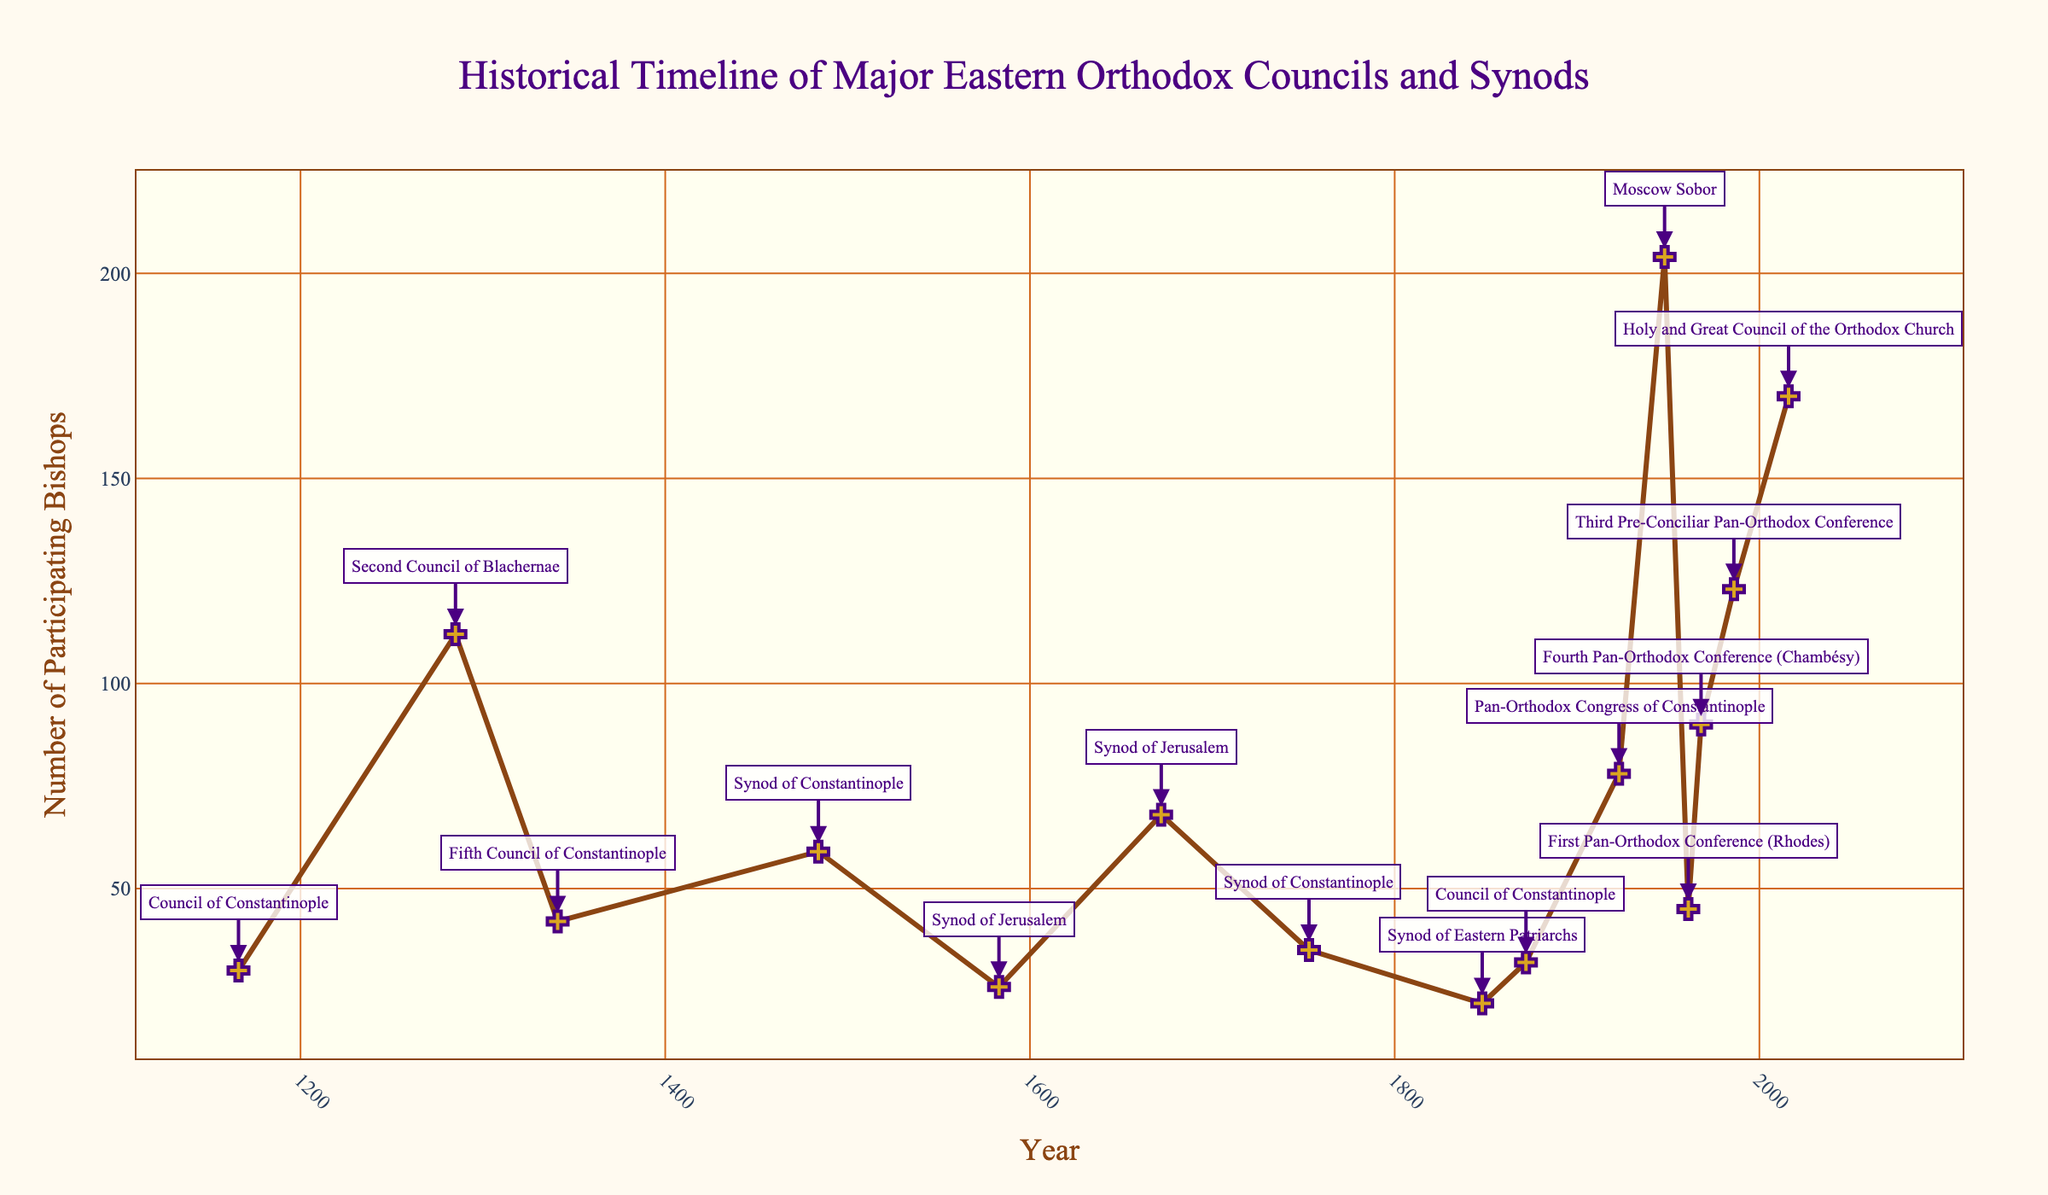Which council had the highest number of participating bishops? Observe the highest point on the y-axis of the plot and note the corresponding year and council/synod annotation. The peak is reached at the Moscow Sobor in 1948 with 204 bishops.
Answer: Moscow Sobor What was the number of participating bishops in the Synod of Jerusalem in 1672? Locate 1672 on the x-axis, then move up vertically to the corresponding line and marker. The annotation at this point indicates the number of participating bishops as 68.
Answer: 68 How did the number of participating bishops change from the Synod of Constantinople in 1484 to the Synod of Jerusalem in 1672? Identify the points for the Synod of Constantinople in 1484 and the Synod of Jerusalem in 1672 on the x-axis, then compare the y-values. In 1484, there were 59 bishops, and in 1672, there were 68 bishops. The difference is 68 - 59 = 9.
Answer: Increased by 9 Which council had a higher number of participating bishops, the Fourth Pan-Orthodox Conference in 1968 or the Holy and Great Council of the Orthodox Church in 2016? Compare the y-values for the events in 1968 and 2016. The Fourth Pan-Orthodox Conference in 1968 had 90 bishops and the Holy and Great Council in 2016 had 170 bishops. 170 is greater than 90.
Answer: Holy and Great Council of the Orthodox Church During which period (before or after 1800) was there a more consistent increase in the number of participating bishops? Examine the trend of the line connecting the data points before and after 1800. Prior to 1800, the number fluctuated with no clear trend; after 1800, there is more evident consistency and increase in the number of participating bishops over time.
Answer: After 1800 What is the average number of participating bishops for all councils held in the 20th century? Identify the relevant data points (1923, 1948, 1961, 1968, 1986) and their corresponding y-values (78, 204, 45, 90, 123). Calculate the average: (78 + 204 + 45 + 90 + 123) / 5. The sum is 540. The average is 540 / 5 = 108.
Answer: 108 Which council had fewer participating bishops, the Fifth Council of Constantinople in 1341 or the Synod of Constantinople in 1753? Compare the y-values for the events in 1341 and 1753. The Fifth Council of Constantinople in 1341 had 42 bishops and the Synod of Constantinople in 1753 had 35 bishops. 35 is less than 42.
Answer: Synod of Constantinople What is the difference in the number of participating bishops between the Pan-Orthodox Congress of Constantinople in 1923 and the Synod of Eastern Patriarchs in 1848? Look at the y-values for the events in 1923 and 1848. The Pan-Orthodox Congress of Constantinople in 1923 had 78 bishops and the Synod of Eastern Patriarchs in 1848 had 22 bishops. The difference is 78 - 22 = 56.
Answer: 56 Which events experienced a decrease in the number of participating bishops compared to the previous one? Examine the y-values sequentially for drops. Notable decreases occurred from the Second Council of Blachernae (1285, 112 bishops) to the Fifth Council of Constantinople (1341, 42 bishops), and from the Moscow Sobor (1948, 204 bishops) to the First Pan-Orthodox Conference (1961, 45 bishops).
Answer: Fifth Council of Constantinople, First Pan-Orthodox Conference 